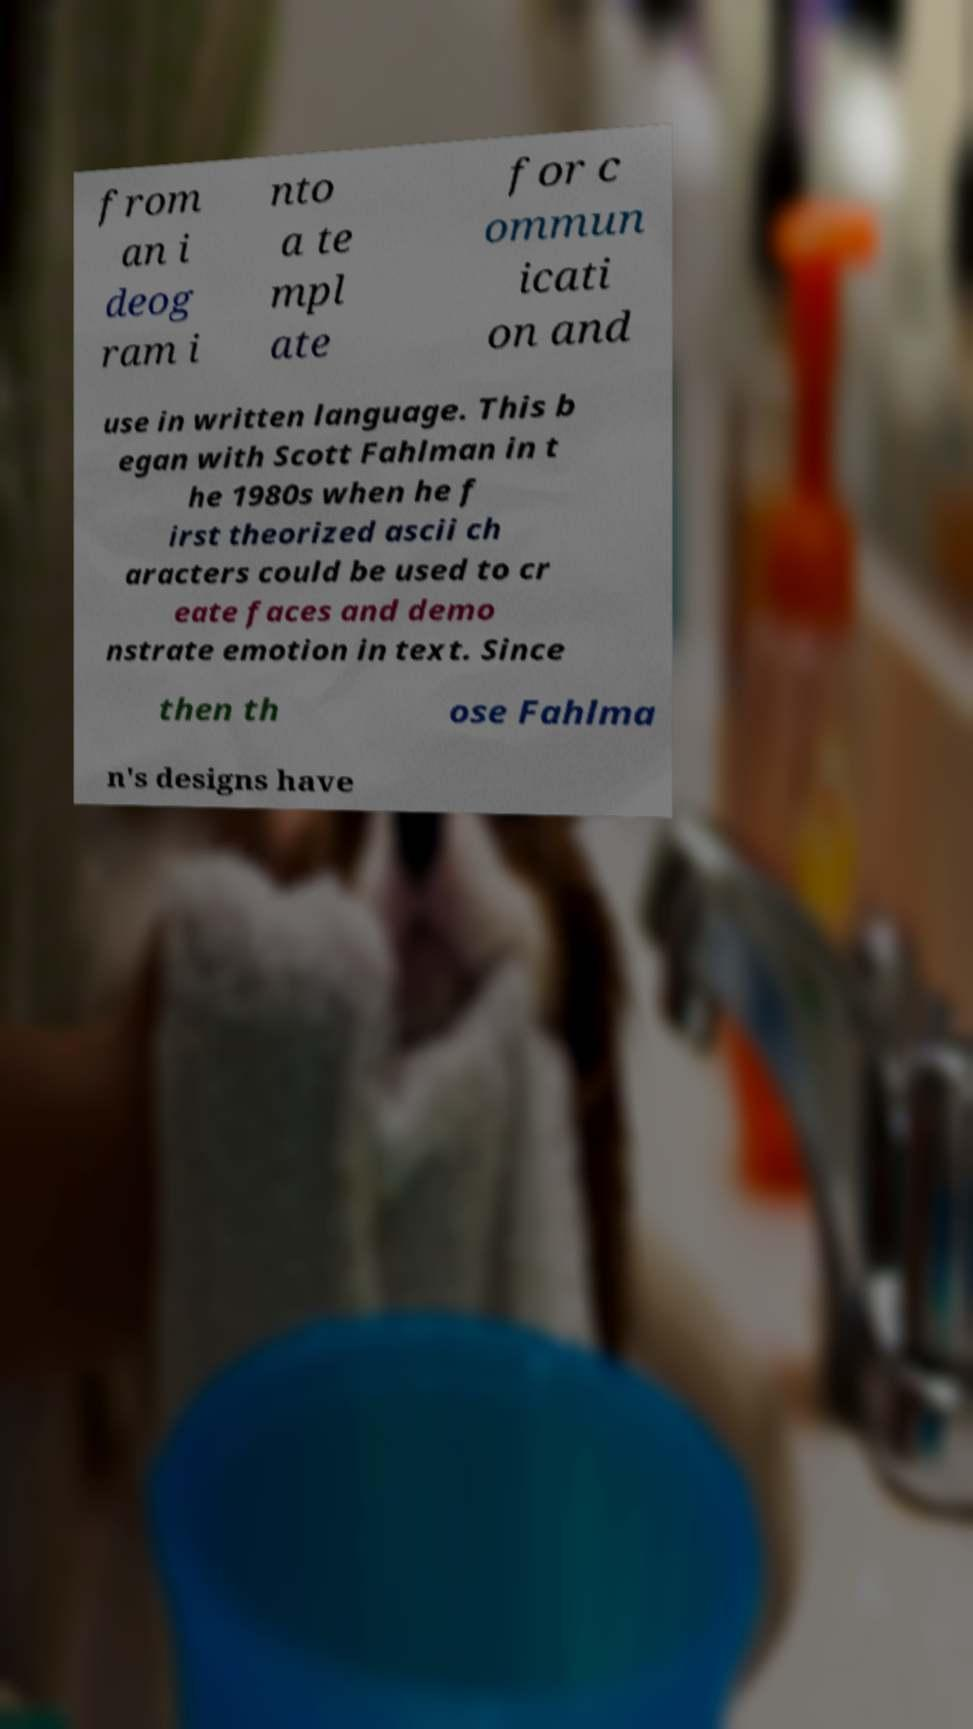For documentation purposes, I need the text within this image transcribed. Could you provide that? from an i deog ram i nto a te mpl ate for c ommun icati on and use in written language. This b egan with Scott Fahlman in t he 1980s when he f irst theorized ascii ch aracters could be used to cr eate faces and demo nstrate emotion in text. Since then th ose Fahlma n's designs have 